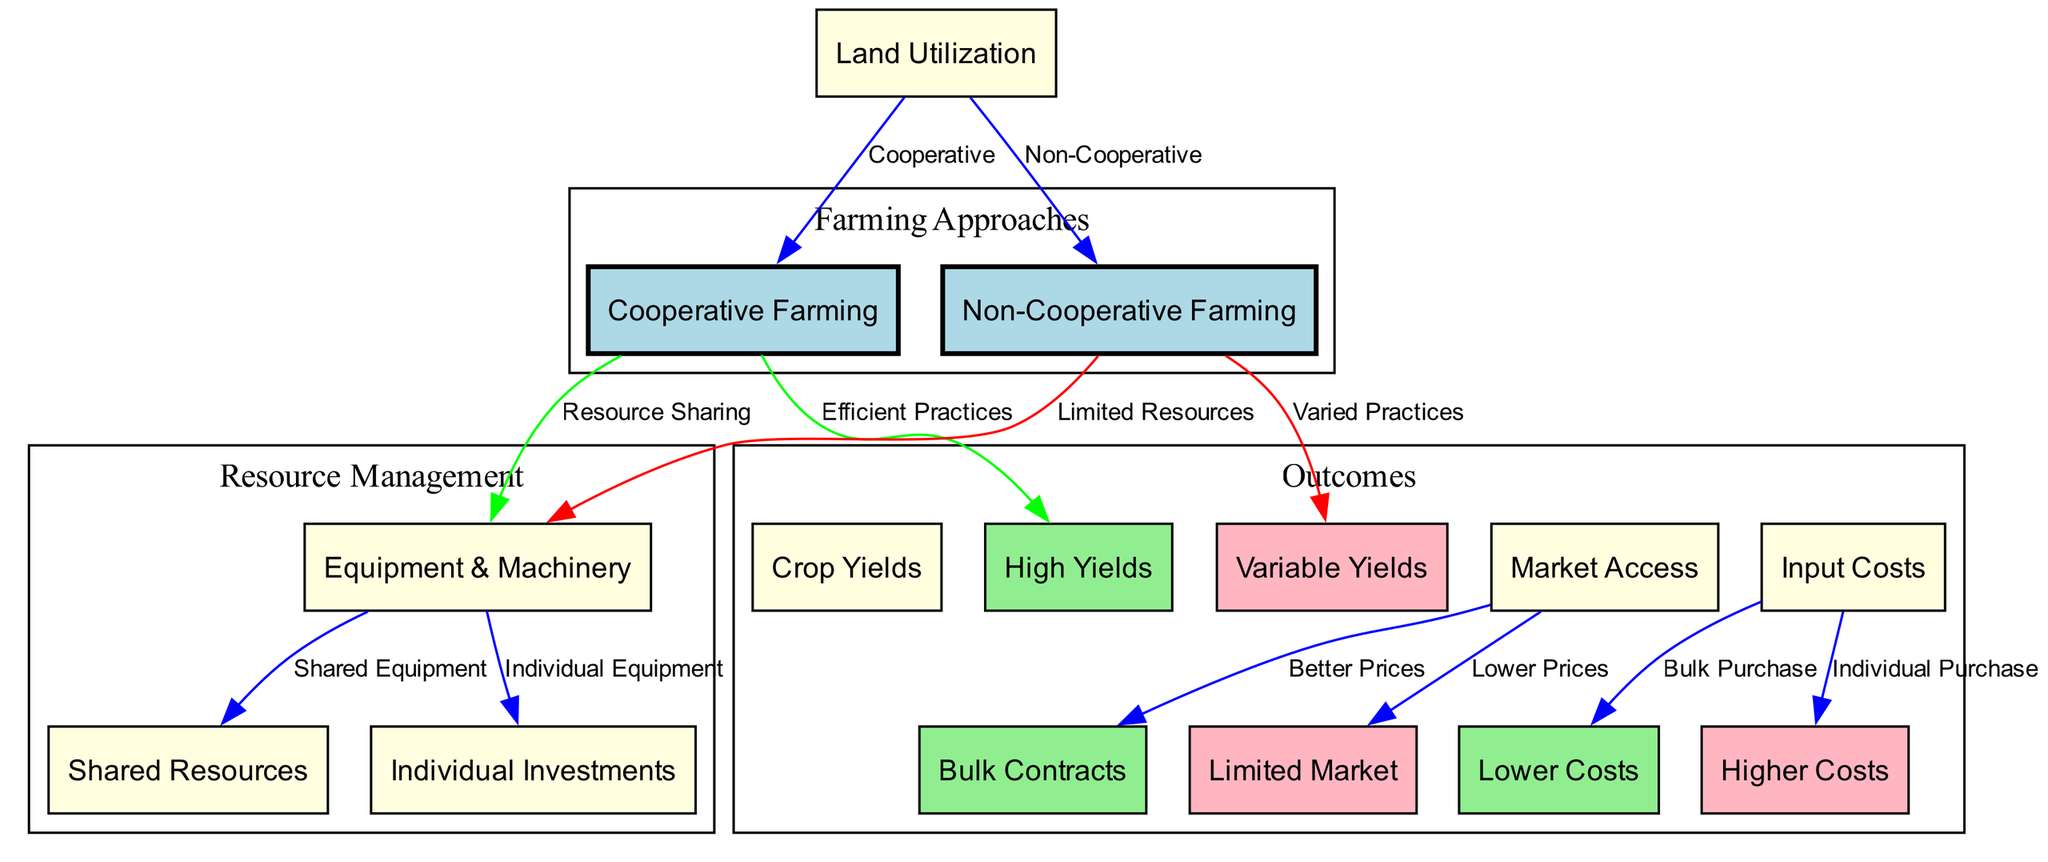What are the two farming approaches depicted in the diagram? The diagram explicitly identifies two farming approaches as "Cooperative Farming" and "Non-Cooperative Farming." These labels are at the root of the diagram under the "Farming Approaches" subgraph.
Answer: Cooperative Farming, Non-Cooperative Farming How many types of resource management are shown? The diagram shows two types of resource management related to farming: "Shared Resources" and "Individual Investments." These are represented under the "Resource Management" subgraph.
Answer: 2 What type of yields does cooperative farming lead to? The diagram indicates that "Cooperative Farming" leads to "High Yields," which is illustrated through a direct connection in the graph that shows efficient practices resulting in improved crop outputs.
Answer: High Yields What is the market access outcome for non-cooperative farming? From the edges connecting "Non-Cooperative Farming" and "Market Access," it is evident that it leads to "Limited Market," implying restricted access compared to cooperative farming setups.
Answer: Limited Market What do bulk purchases lead to regarding input costs? The diagram shows that "Bulk Purchase" leads to "Lower Costs." This relationship is indicated by the edge connecting the input costs to the respective outcomes of resource management.
Answer: Lower Costs Which type of equipment and machinery is shared in cooperative farming? The diagram notes that in "Cooperative Farming," there is a connection to "Shared Resources," indicating the pooling of equipment and machinery as a collaborative approach.
Answer: Shared Equipment What relationship do individual purchases have with input costs? The edge connecting "Individual Purchase" directly to "Higher Costs" shows that individual investments in equipment and resources result in elevated input costs compared to cooperative efforts.
Answer: Higher Costs What is the impact of efficient practices on crop yields? The direct edge from "Efficient Practices" to "High Yields" in the diagram suggests that these practices significantly enhance the productivity of crops, which is a key advantage of cooperative farming.
Answer: High Yields What type of contracts can cooperative farmers access? According to the diagram, "Market Access" connected to "Bulk Contracts" indicates that cooperative farmers are likely to benefit from better contractual deals due to their collective bargaining power.
Answer: Bulk Contracts 